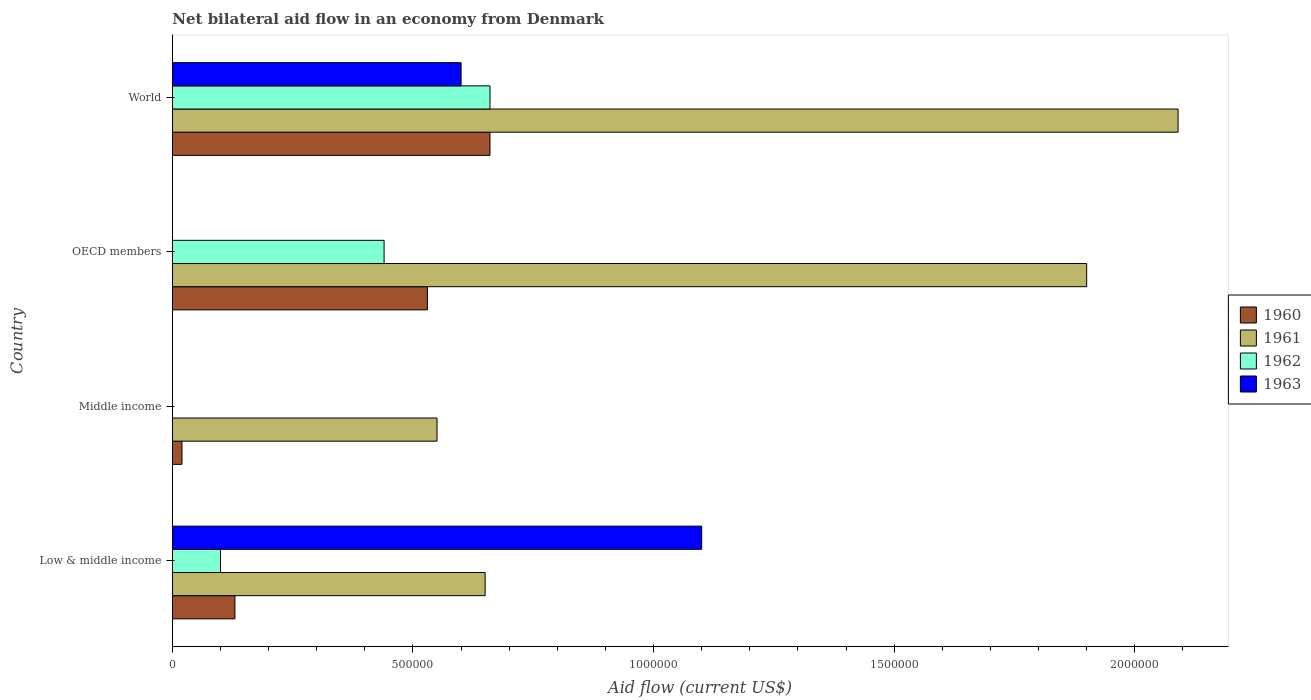How many different coloured bars are there?
Your answer should be very brief. 4. Are the number of bars per tick equal to the number of legend labels?
Offer a terse response. No. In how many cases, is the number of bars for a given country not equal to the number of legend labels?
Offer a terse response. 2. Across all countries, what is the minimum net bilateral aid flow in 1960?
Your response must be concise. 2.00e+04. In which country was the net bilateral aid flow in 1963 maximum?
Provide a succinct answer. Low & middle income. What is the total net bilateral aid flow in 1960 in the graph?
Ensure brevity in your answer.  1.34e+06. What is the average net bilateral aid flow in 1961 per country?
Keep it short and to the point. 1.30e+06. What is the difference between the net bilateral aid flow in 1961 and net bilateral aid flow in 1963 in Low & middle income?
Your response must be concise. -4.50e+05. What is the ratio of the net bilateral aid flow in 1960 in Low & middle income to that in World?
Provide a short and direct response. 0.2. Is the difference between the net bilateral aid flow in 1961 in Low & middle income and World greater than the difference between the net bilateral aid flow in 1963 in Low & middle income and World?
Make the answer very short. No. What is the difference between the highest and the lowest net bilateral aid flow in 1961?
Your answer should be compact. 1.54e+06. Is the sum of the net bilateral aid flow in 1960 in Low & middle income and OECD members greater than the maximum net bilateral aid flow in 1961 across all countries?
Offer a terse response. No. Is it the case that in every country, the sum of the net bilateral aid flow in 1962 and net bilateral aid flow in 1960 is greater than the sum of net bilateral aid flow in 1961 and net bilateral aid flow in 1963?
Provide a short and direct response. No. Are all the bars in the graph horizontal?
Offer a very short reply. Yes. How many countries are there in the graph?
Offer a terse response. 4. Are the values on the major ticks of X-axis written in scientific E-notation?
Ensure brevity in your answer.  No. Does the graph contain any zero values?
Provide a short and direct response. Yes. What is the title of the graph?
Offer a very short reply. Net bilateral aid flow in an economy from Denmark. What is the label or title of the Y-axis?
Your answer should be very brief. Country. What is the Aid flow (current US$) in 1961 in Low & middle income?
Your answer should be compact. 6.50e+05. What is the Aid flow (current US$) of 1963 in Low & middle income?
Your answer should be very brief. 1.10e+06. What is the Aid flow (current US$) in 1961 in Middle income?
Your response must be concise. 5.50e+05. What is the Aid flow (current US$) of 1962 in Middle income?
Offer a terse response. 0. What is the Aid flow (current US$) of 1960 in OECD members?
Offer a terse response. 5.30e+05. What is the Aid flow (current US$) of 1961 in OECD members?
Offer a terse response. 1.90e+06. What is the Aid flow (current US$) of 1962 in OECD members?
Keep it short and to the point. 4.40e+05. What is the Aid flow (current US$) in 1960 in World?
Your answer should be compact. 6.60e+05. What is the Aid flow (current US$) of 1961 in World?
Your response must be concise. 2.09e+06. What is the Aid flow (current US$) of 1963 in World?
Offer a terse response. 6.00e+05. Across all countries, what is the maximum Aid flow (current US$) in 1961?
Your response must be concise. 2.09e+06. Across all countries, what is the maximum Aid flow (current US$) of 1962?
Offer a terse response. 6.60e+05. Across all countries, what is the maximum Aid flow (current US$) of 1963?
Provide a succinct answer. 1.10e+06. Across all countries, what is the minimum Aid flow (current US$) in 1960?
Your response must be concise. 2.00e+04. What is the total Aid flow (current US$) in 1960 in the graph?
Ensure brevity in your answer.  1.34e+06. What is the total Aid flow (current US$) in 1961 in the graph?
Your answer should be compact. 5.19e+06. What is the total Aid flow (current US$) of 1962 in the graph?
Give a very brief answer. 1.20e+06. What is the total Aid flow (current US$) of 1963 in the graph?
Keep it short and to the point. 1.70e+06. What is the difference between the Aid flow (current US$) in 1960 in Low & middle income and that in Middle income?
Ensure brevity in your answer.  1.10e+05. What is the difference between the Aid flow (current US$) of 1961 in Low & middle income and that in Middle income?
Keep it short and to the point. 1.00e+05. What is the difference between the Aid flow (current US$) of 1960 in Low & middle income and that in OECD members?
Offer a very short reply. -4.00e+05. What is the difference between the Aid flow (current US$) of 1961 in Low & middle income and that in OECD members?
Offer a very short reply. -1.25e+06. What is the difference between the Aid flow (current US$) in 1960 in Low & middle income and that in World?
Ensure brevity in your answer.  -5.30e+05. What is the difference between the Aid flow (current US$) of 1961 in Low & middle income and that in World?
Keep it short and to the point. -1.44e+06. What is the difference between the Aid flow (current US$) of 1962 in Low & middle income and that in World?
Your answer should be very brief. -5.60e+05. What is the difference between the Aid flow (current US$) of 1963 in Low & middle income and that in World?
Give a very brief answer. 5.00e+05. What is the difference between the Aid flow (current US$) of 1960 in Middle income and that in OECD members?
Keep it short and to the point. -5.10e+05. What is the difference between the Aid flow (current US$) of 1961 in Middle income and that in OECD members?
Ensure brevity in your answer.  -1.35e+06. What is the difference between the Aid flow (current US$) of 1960 in Middle income and that in World?
Keep it short and to the point. -6.40e+05. What is the difference between the Aid flow (current US$) of 1961 in Middle income and that in World?
Make the answer very short. -1.54e+06. What is the difference between the Aid flow (current US$) of 1960 in OECD members and that in World?
Provide a short and direct response. -1.30e+05. What is the difference between the Aid flow (current US$) in 1961 in OECD members and that in World?
Provide a succinct answer. -1.90e+05. What is the difference between the Aid flow (current US$) of 1962 in OECD members and that in World?
Provide a short and direct response. -2.20e+05. What is the difference between the Aid flow (current US$) of 1960 in Low & middle income and the Aid flow (current US$) of 1961 in Middle income?
Provide a short and direct response. -4.20e+05. What is the difference between the Aid flow (current US$) in 1960 in Low & middle income and the Aid flow (current US$) in 1961 in OECD members?
Offer a very short reply. -1.77e+06. What is the difference between the Aid flow (current US$) of 1960 in Low & middle income and the Aid flow (current US$) of 1962 in OECD members?
Your answer should be very brief. -3.10e+05. What is the difference between the Aid flow (current US$) of 1961 in Low & middle income and the Aid flow (current US$) of 1962 in OECD members?
Provide a succinct answer. 2.10e+05. What is the difference between the Aid flow (current US$) in 1960 in Low & middle income and the Aid flow (current US$) in 1961 in World?
Your response must be concise. -1.96e+06. What is the difference between the Aid flow (current US$) of 1960 in Low & middle income and the Aid flow (current US$) of 1962 in World?
Provide a short and direct response. -5.30e+05. What is the difference between the Aid flow (current US$) in 1960 in Low & middle income and the Aid flow (current US$) in 1963 in World?
Offer a terse response. -4.70e+05. What is the difference between the Aid flow (current US$) in 1961 in Low & middle income and the Aid flow (current US$) in 1963 in World?
Keep it short and to the point. 5.00e+04. What is the difference between the Aid flow (current US$) in 1962 in Low & middle income and the Aid flow (current US$) in 1963 in World?
Your response must be concise. -5.00e+05. What is the difference between the Aid flow (current US$) in 1960 in Middle income and the Aid flow (current US$) in 1961 in OECD members?
Provide a succinct answer. -1.88e+06. What is the difference between the Aid flow (current US$) of 1960 in Middle income and the Aid flow (current US$) of 1962 in OECD members?
Offer a very short reply. -4.20e+05. What is the difference between the Aid flow (current US$) in 1960 in Middle income and the Aid flow (current US$) in 1961 in World?
Offer a terse response. -2.07e+06. What is the difference between the Aid flow (current US$) in 1960 in Middle income and the Aid flow (current US$) in 1962 in World?
Provide a succinct answer. -6.40e+05. What is the difference between the Aid flow (current US$) of 1960 in Middle income and the Aid flow (current US$) of 1963 in World?
Provide a short and direct response. -5.80e+05. What is the difference between the Aid flow (current US$) in 1960 in OECD members and the Aid flow (current US$) in 1961 in World?
Offer a very short reply. -1.56e+06. What is the difference between the Aid flow (current US$) in 1960 in OECD members and the Aid flow (current US$) in 1962 in World?
Your answer should be very brief. -1.30e+05. What is the difference between the Aid flow (current US$) of 1961 in OECD members and the Aid flow (current US$) of 1962 in World?
Your answer should be very brief. 1.24e+06. What is the difference between the Aid flow (current US$) of 1961 in OECD members and the Aid flow (current US$) of 1963 in World?
Ensure brevity in your answer.  1.30e+06. What is the average Aid flow (current US$) of 1960 per country?
Your response must be concise. 3.35e+05. What is the average Aid flow (current US$) in 1961 per country?
Your response must be concise. 1.30e+06. What is the average Aid flow (current US$) in 1962 per country?
Ensure brevity in your answer.  3.00e+05. What is the average Aid flow (current US$) in 1963 per country?
Your answer should be very brief. 4.25e+05. What is the difference between the Aid flow (current US$) of 1960 and Aid flow (current US$) of 1961 in Low & middle income?
Ensure brevity in your answer.  -5.20e+05. What is the difference between the Aid flow (current US$) in 1960 and Aid flow (current US$) in 1962 in Low & middle income?
Ensure brevity in your answer.  3.00e+04. What is the difference between the Aid flow (current US$) in 1960 and Aid flow (current US$) in 1963 in Low & middle income?
Make the answer very short. -9.70e+05. What is the difference between the Aid flow (current US$) in 1961 and Aid flow (current US$) in 1962 in Low & middle income?
Ensure brevity in your answer.  5.50e+05. What is the difference between the Aid flow (current US$) in 1961 and Aid flow (current US$) in 1963 in Low & middle income?
Your response must be concise. -4.50e+05. What is the difference between the Aid flow (current US$) in 1960 and Aid flow (current US$) in 1961 in Middle income?
Make the answer very short. -5.30e+05. What is the difference between the Aid flow (current US$) in 1960 and Aid flow (current US$) in 1961 in OECD members?
Offer a very short reply. -1.37e+06. What is the difference between the Aid flow (current US$) in 1961 and Aid flow (current US$) in 1962 in OECD members?
Make the answer very short. 1.46e+06. What is the difference between the Aid flow (current US$) of 1960 and Aid flow (current US$) of 1961 in World?
Make the answer very short. -1.43e+06. What is the difference between the Aid flow (current US$) in 1960 and Aid flow (current US$) in 1962 in World?
Offer a terse response. 0. What is the difference between the Aid flow (current US$) of 1960 and Aid flow (current US$) of 1963 in World?
Make the answer very short. 6.00e+04. What is the difference between the Aid flow (current US$) of 1961 and Aid flow (current US$) of 1962 in World?
Your response must be concise. 1.43e+06. What is the difference between the Aid flow (current US$) of 1961 and Aid flow (current US$) of 1963 in World?
Your answer should be very brief. 1.49e+06. What is the ratio of the Aid flow (current US$) of 1960 in Low & middle income to that in Middle income?
Your answer should be compact. 6.5. What is the ratio of the Aid flow (current US$) in 1961 in Low & middle income to that in Middle income?
Your response must be concise. 1.18. What is the ratio of the Aid flow (current US$) of 1960 in Low & middle income to that in OECD members?
Your answer should be compact. 0.25. What is the ratio of the Aid flow (current US$) of 1961 in Low & middle income to that in OECD members?
Your answer should be compact. 0.34. What is the ratio of the Aid flow (current US$) in 1962 in Low & middle income to that in OECD members?
Offer a terse response. 0.23. What is the ratio of the Aid flow (current US$) of 1960 in Low & middle income to that in World?
Make the answer very short. 0.2. What is the ratio of the Aid flow (current US$) in 1961 in Low & middle income to that in World?
Provide a short and direct response. 0.31. What is the ratio of the Aid flow (current US$) in 1962 in Low & middle income to that in World?
Make the answer very short. 0.15. What is the ratio of the Aid flow (current US$) in 1963 in Low & middle income to that in World?
Make the answer very short. 1.83. What is the ratio of the Aid flow (current US$) in 1960 in Middle income to that in OECD members?
Your answer should be compact. 0.04. What is the ratio of the Aid flow (current US$) in 1961 in Middle income to that in OECD members?
Make the answer very short. 0.29. What is the ratio of the Aid flow (current US$) in 1960 in Middle income to that in World?
Provide a succinct answer. 0.03. What is the ratio of the Aid flow (current US$) in 1961 in Middle income to that in World?
Provide a short and direct response. 0.26. What is the ratio of the Aid flow (current US$) in 1960 in OECD members to that in World?
Ensure brevity in your answer.  0.8. What is the ratio of the Aid flow (current US$) in 1961 in OECD members to that in World?
Offer a very short reply. 0.91. What is the difference between the highest and the second highest Aid flow (current US$) of 1960?
Make the answer very short. 1.30e+05. What is the difference between the highest and the second highest Aid flow (current US$) of 1961?
Ensure brevity in your answer.  1.90e+05. What is the difference between the highest and the second highest Aid flow (current US$) of 1962?
Ensure brevity in your answer.  2.20e+05. What is the difference between the highest and the lowest Aid flow (current US$) of 1960?
Keep it short and to the point. 6.40e+05. What is the difference between the highest and the lowest Aid flow (current US$) in 1961?
Offer a terse response. 1.54e+06. What is the difference between the highest and the lowest Aid flow (current US$) in 1962?
Keep it short and to the point. 6.60e+05. What is the difference between the highest and the lowest Aid flow (current US$) in 1963?
Ensure brevity in your answer.  1.10e+06. 